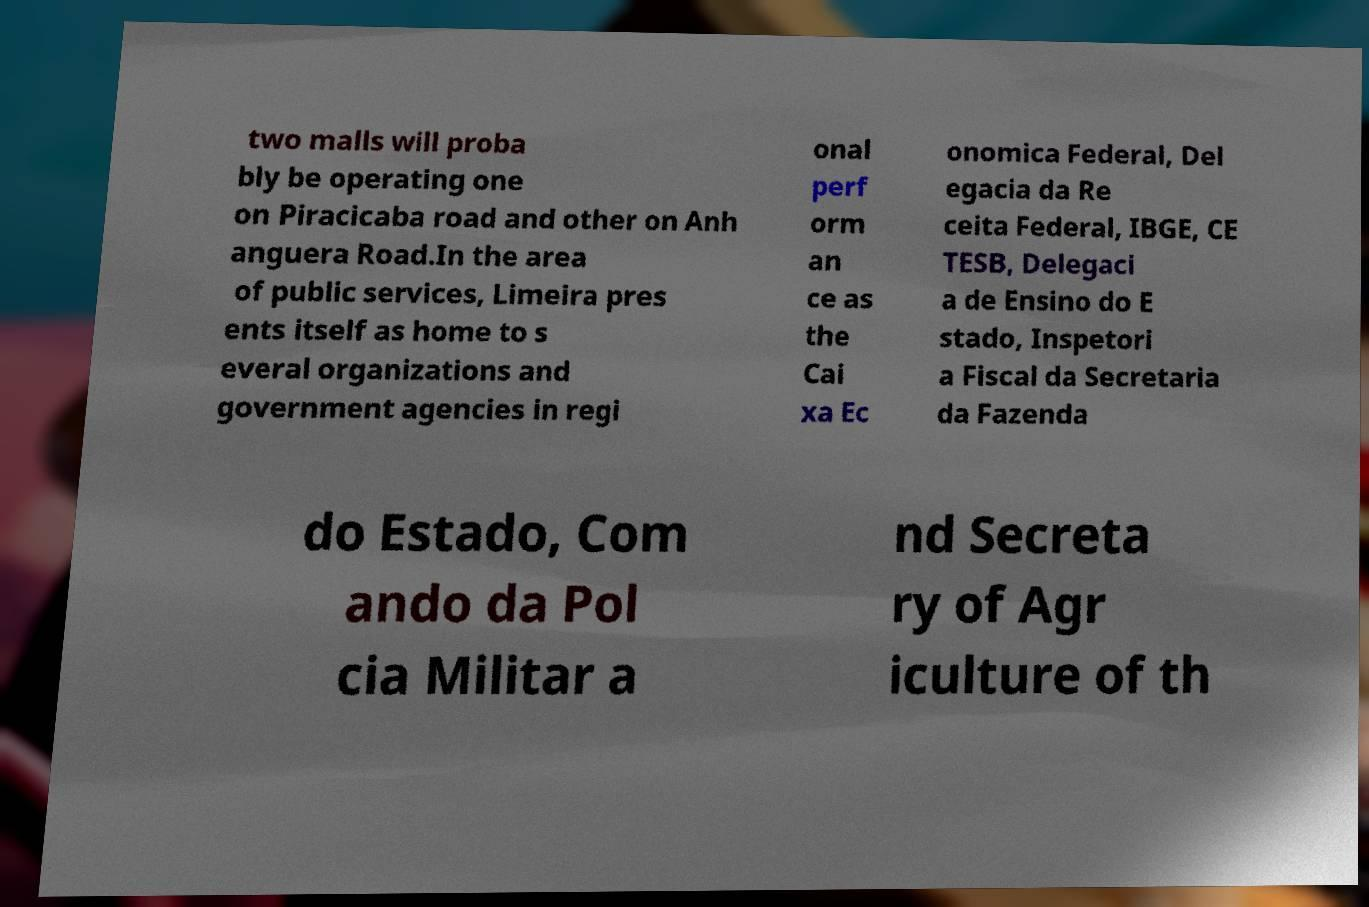There's text embedded in this image that I need extracted. Can you transcribe it verbatim? two malls will proba bly be operating one on Piracicaba road and other on Anh anguera Road.In the area of public services, Limeira pres ents itself as home to s everal organizations and government agencies in regi onal perf orm an ce as the Cai xa Ec onomica Federal, Del egacia da Re ceita Federal, IBGE, CE TESB, Delegaci a de Ensino do E stado, Inspetori a Fiscal da Secretaria da Fazenda do Estado, Com ando da Pol cia Militar a nd Secreta ry of Agr iculture of th 